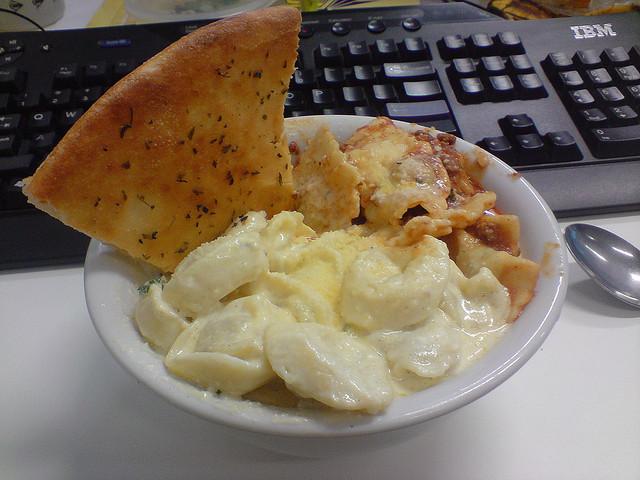What is the plate sitting on?
Keep it brief. Desk. Is this on a plate or in a bowl?
Answer briefly. Bowl. What utensil can be seen?
Quick response, please. Spoon. What color is the keyboard?
Keep it brief. Black. 